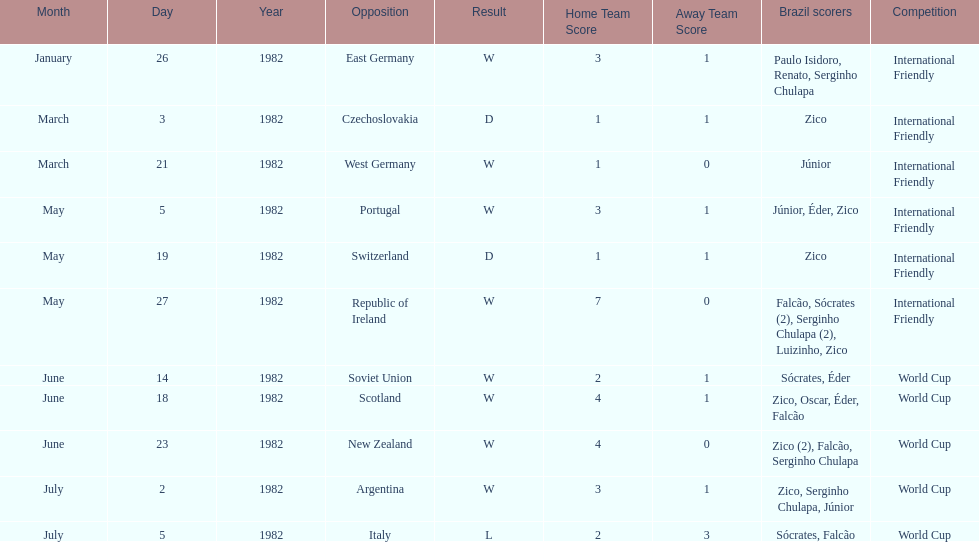What was the total number of losses brazil suffered? 1. 